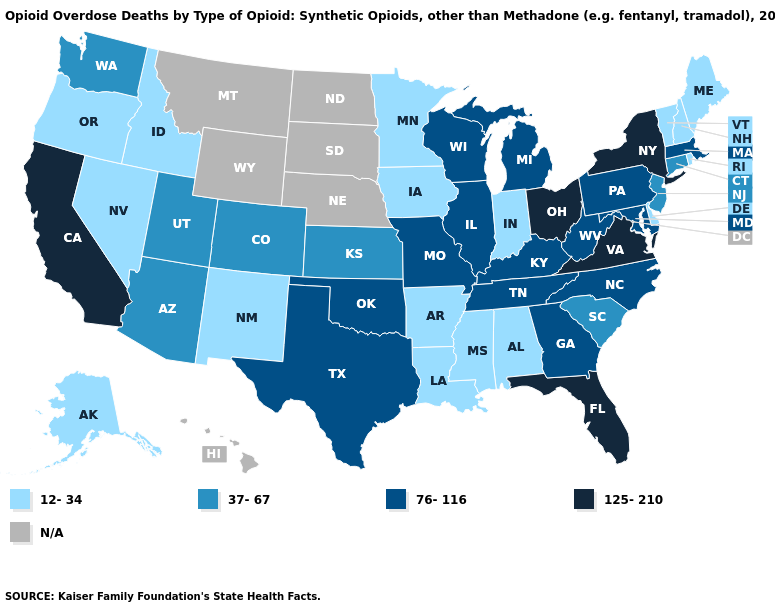What is the lowest value in states that border Pennsylvania?
Answer briefly. 12-34. Among the states that border Florida , does Alabama have the highest value?
Short answer required. No. What is the lowest value in the USA?
Answer briefly. 12-34. Name the states that have a value in the range 76-116?
Keep it brief. Georgia, Illinois, Kentucky, Maryland, Massachusetts, Michigan, Missouri, North Carolina, Oklahoma, Pennsylvania, Tennessee, Texas, West Virginia, Wisconsin. Name the states that have a value in the range 37-67?
Write a very short answer. Arizona, Colorado, Connecticut, Kansas, New Jersey, South Carolina, Utah, Washington. What is the value of Utah?
Quick response, please. 37-67. What is the lowest value in states that border Louisiana?
Keep it brief. 12-34. What is the highest value in states that border Colorado?
Give a very brief answer. 76-116. Is the legend a continuous bar?
Concise answer only. No. What is the lowest value in the USA?
Short answer required. 12-34. Does Alabama have the lowest value in the South?
Concise answer only. Yes. How many symbols are there in the legend?
Concise answer only. 5. Name the states that have a value in the range 37-67?
Quick response, please. Arizona, Colorado, Connecticut, Kansas, New Jersey, South Carolina, Utah, Washington. 